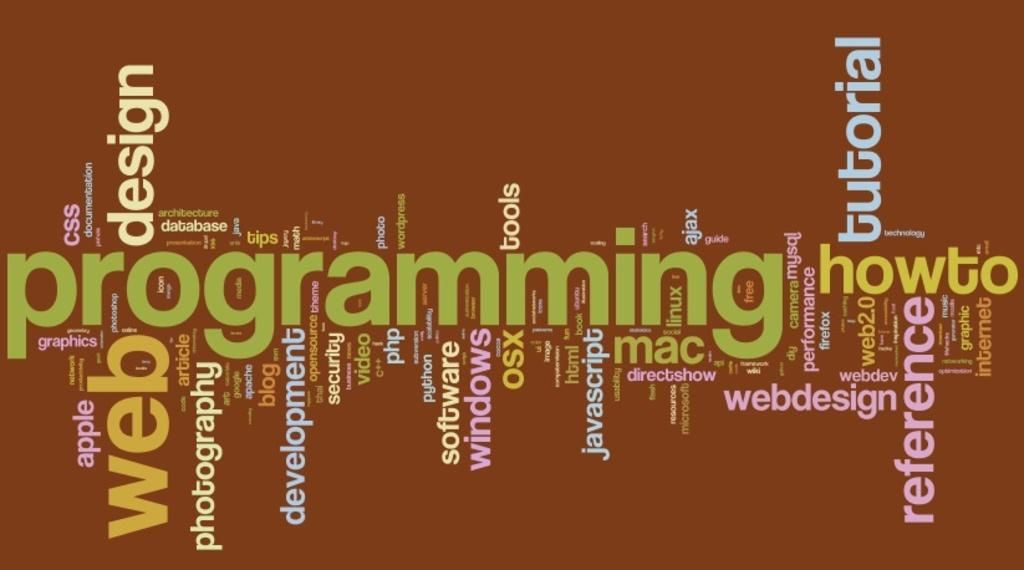<image>
Relay a brief, clear account of the picture shown. A programming how to advertisement with a brown background. 